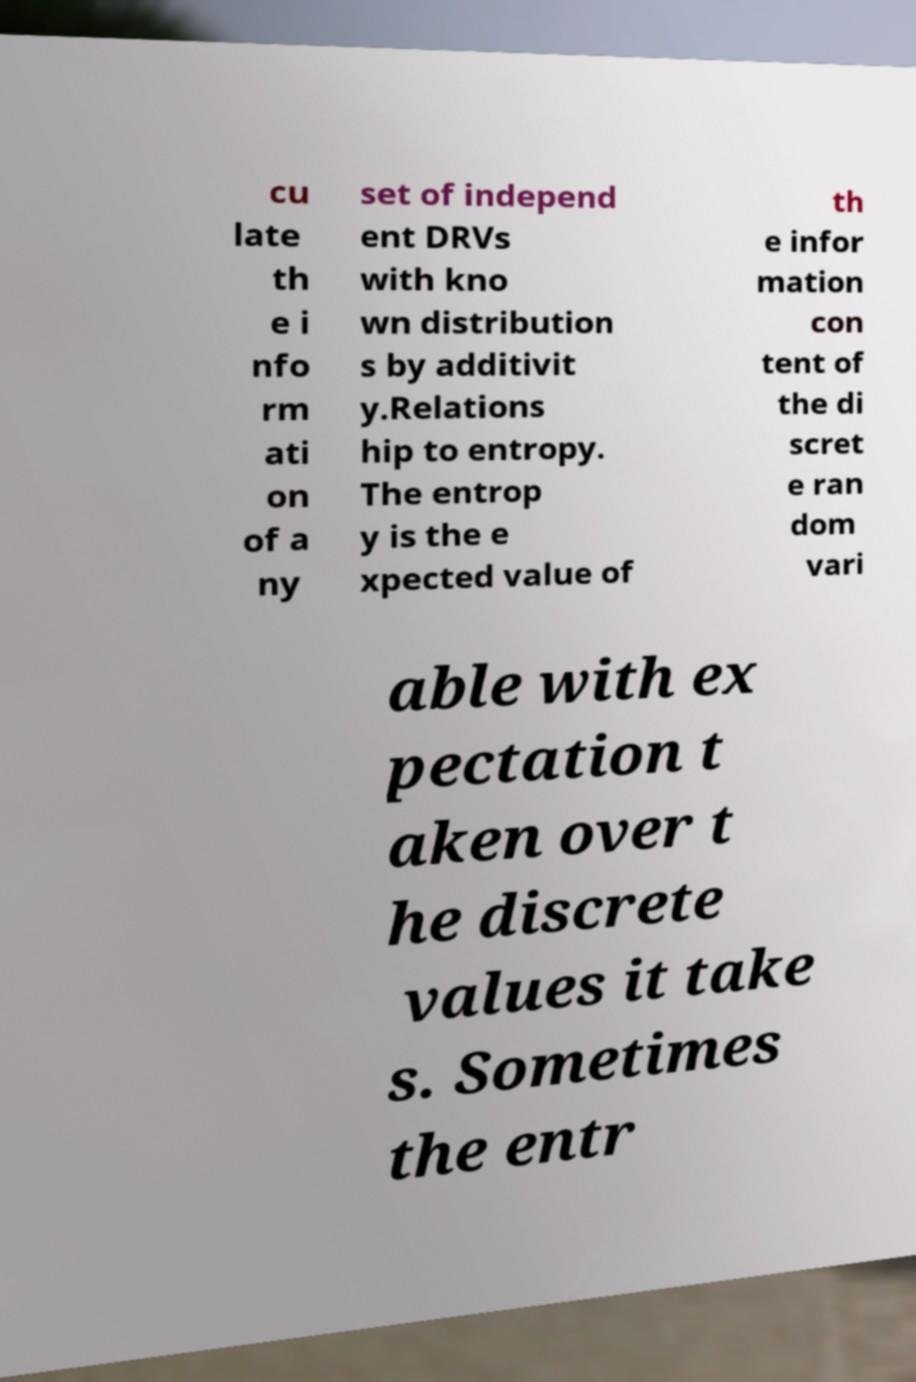Please read and relay the text visible in this image. What does it say? cu late th e i nfo rm ati on of a ny set of independ ent DRVs with kno wn distribution s by additivit y.Relations hip to entropy. The entrop y is the e xpected value of th e infor mation con tent of the di scret e ran dom vari able with ex pectation t aken over t he discrete values it take s. Sometimes the entr 